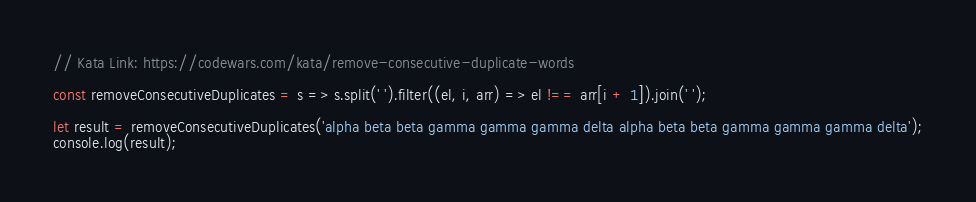Convert code to text. <code><loc_0><loc_0><loc_500><loc_500><_JavaScript_>// Kata Link: https://codewars.com/kata/remove-consecutive-duplicate-words

const removeConsecutiveDuplicates = s => s.split(' ').filter((el, i, arr) => el !== arr[i + 1]).join(' ');

let result = removeConsecutiveDuplicates('alpha beta beta gamma gamma gamma delta alpha beta beta gamma gamma gamma delta');
console.log(result);</code> 